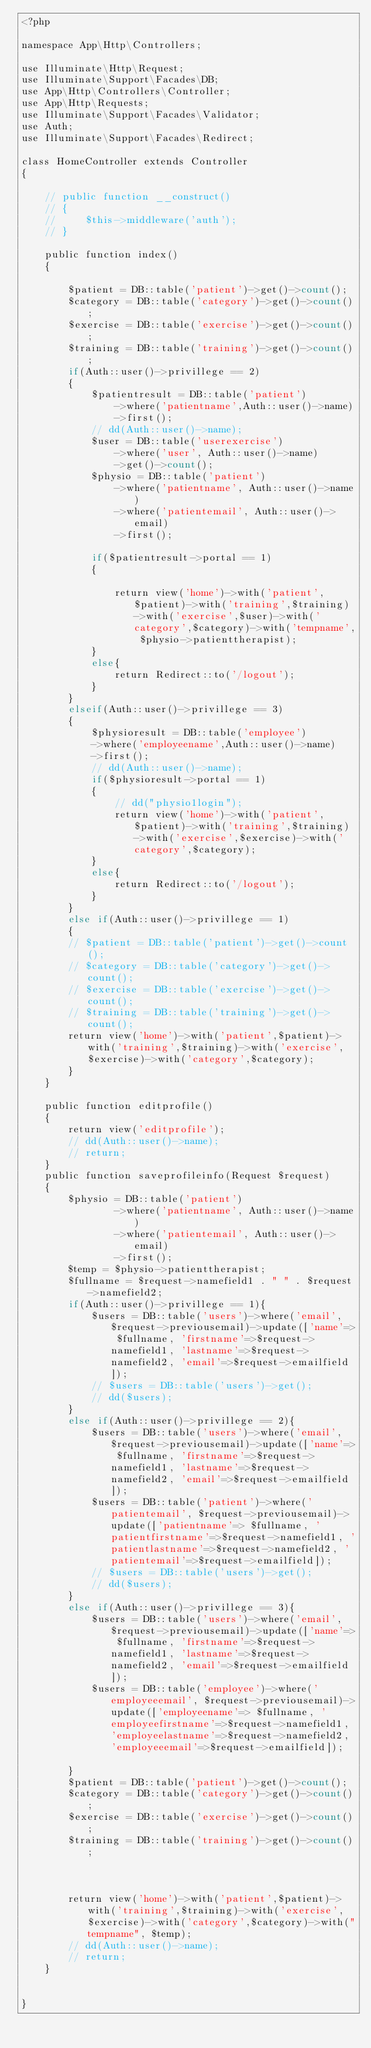<code> <loc_0><loc_0><loc_500><loc_500><_PHP_><?php

namespace App\Http\Controllers;

use Illuminate\Http\Request;
use Illuminate\Support\Facades\DB;
use App\Http\Controllers\Controller;
use App\Http\Requests;
use Illuminate\Support\Facades\Validator;
use Auth;
use Illuminate\Support\Facades\Redirect;

class HomeController extends Controller
{
    
    // public function __construct()
    // {
    //     $this->middleware('auth');
    // }

    public function index()
    {
       
        $patient = DB::table('patient')->get()->count();
        $category = DB::table('category')->get()->count();
        $exercise = DB::table('exercise')->get()->count();
        $training = DB::table('training')->get()->count();
        if(Auth::user()->privillege == 2)
        {
            $patientresult = DB::table('patient')
                ->where('patientname',Auth::user()->name)
                ->first();
            // dd(Auth::user()->name);
            $user = DB::table('userexercise')
                ->where('user', Auth::user()->name)
                ->get()->count();
            $physio = DB::table('patient')
                ->where('patientname', Auth::user()->name)
                ->where('patientemail', Auth::user()->email)
                ->first();
           
            if($patientresult->portal == 1)
            {
               
                return view('home')->with('patient',$patient)->with('training',$training)->with('exercise',$user)->with('category',$category)->with('tempname', $physio->patienttherapist);
            }
            else{
                return Redirect::to('/logout');
            }
        }
        elseif(Auth::user()->privillege == 3)
        {
            $physioresult = DB::table('employee')
            ->where('employeename',Auth::user()->name)
            ->first();
            // dd(Auth::user()->name);
            if($physioresult->portal == 1)
            {
                // dd("physio1login");
                return view('home')->with('patient',$patient)->with('training',$training)->with('exercise',$exercise)->with('category',$category);
            }
            else{
                return Redirect::to('/logout');
            }
        }
        else if(Auth::user()->privillege == 1)
        {
        // $patient = DB::table('patient')->get()->count();
        // $category = DB::table('category')->get()->count();
        // $exercise = DB::table('exercise')->get()->count();
        // $training = DB::table('training')->get()->count();
        return view('home')->with('patient',$patient)->with('training',$training)->with('exercise',$exercise)->with('category',$category);
        }
    }

    public function editprofile()
    {
        return view('editprofile');
        // dd(Auth::user()->name);
        // return;
    }
    public function saveprofileinfo(Request $request)
    {
        $physio = DB::table('patient')
                ->where('patientname', Auth::user()->name)
                ->where('patientemail', Auth::user()->email)
                ->first();
        $temp = $physio->patienttherapist;
        $fullname = $request->namefield1 . " " . $request->namefield2;
        if(Auth::user()->privillege == 1){
            $users = DB::table('users')->where('email', $request->previousemail)->update(['name'=> $fullname, 'firstname'=>$request->namefield1, 'lastname'=>$request->namefield2, 'email'=>$request->emailfield]);
            // $users = DB::table('users')->get();
            // dd($users);
        }
        else if(Auth::user()->privillege == 2){
            $users = DB::table('users')->where('email', $request->previousemail)->update(['name'=> $fullname, 'firstname'=>$request->namefield1, 'lastname'=>$request->namefield2, 'email'=>$request->emailfield]);
            $users = DB::table('patient')->where('patientemail', $request->previousemail)->update(['patientname'=> $fullname, 'patientfirstname'=>$request->namefield1, 'patientlastname'=>$request->namefield2, 'patientemail'=>$request->emailfield]);
            // $users = DB::table('users')->get();
            // dd($users);
        }
        else if(Auth::user()->privillege == 3){
            $users = DB::table('users')->where('email', $request->previousemail)->update(['name'=> $fullname, 'firstname'=>$request->namefield1, 'lastname'=>$request->namefield2, 'email'=>$request->emailfield]);
            $users = DB::table('employee')->where('employeeemail', $request->previousemail)->update(['employeename'=> $fullname, 'employeefirstname'=>$request->namefield1, 'employeelastname'=>$request->namefield2, 'employeeemail'=>$request->emailfield]);
           
        }
        $patient = DB::table('patient')->get()->count();
        $category = DB::table('category')->get()->count();
        $exercise = DB::table('exercise')->get()->count();
        $training = DB::table('training')->get()->count();

        
        
        return view('home')->with('patient',$patient)->with('training',$training)->with('exercise',$exercise)->with('category',$category)->with("tempname", $temp);
        // dd(Auth::user()->name);
        // return;
    }

    
}
</code> 